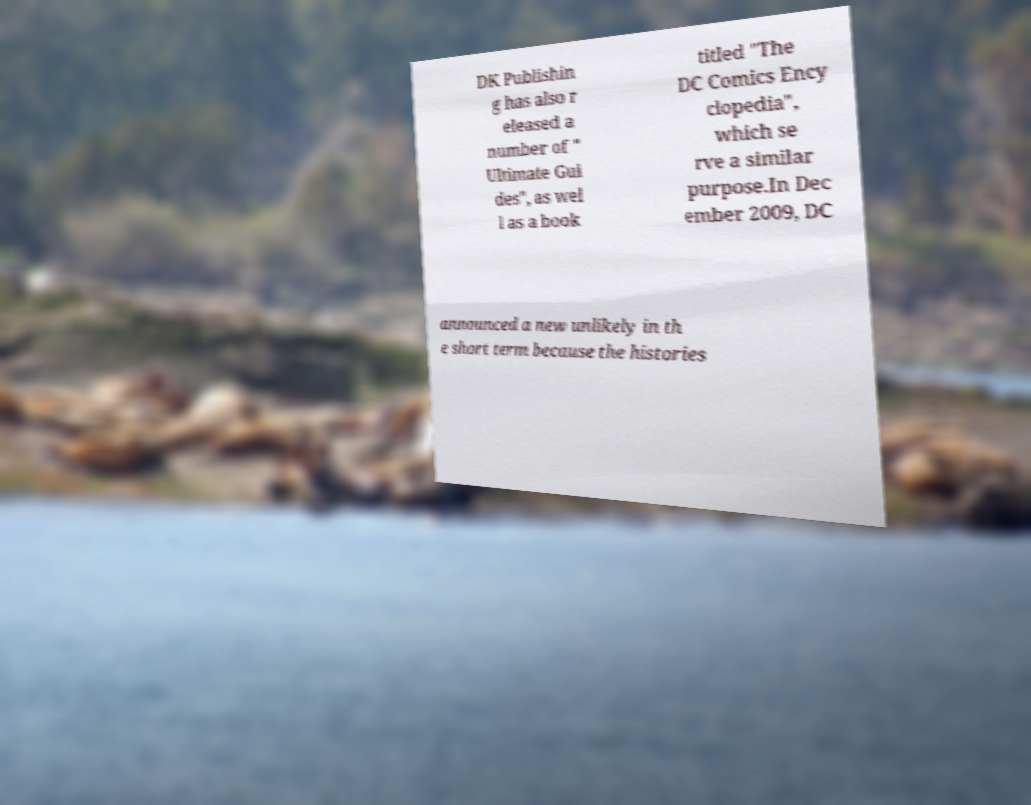There's text embedded in this image that I need extracted. Can you transcribe it verbatim? DK Publishin g has also r eleased a number of " Ultimate Gui des", as wel l as a book titled "The DC Comics Ency clopedia", which se rve a similar purpose.In Dec ember 2009, DC announced a new unlikely in th e short term because the histories 